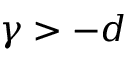Convert formula to latex. <formula><loc_0><loc_0><loc_500><loc_500>\gamma > - d</formula> 